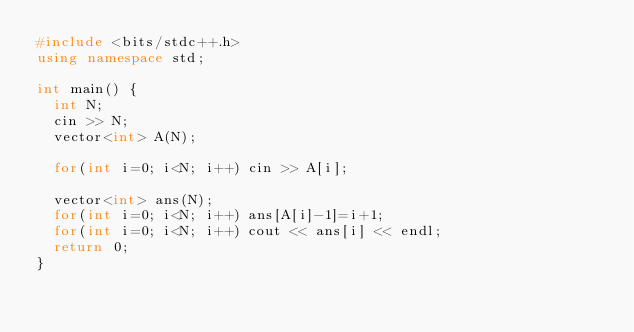<code> <loc_0><loc_0><loc_500><loc_500><_C++_>#include <bits/stdc++.h>
using namespace std;

int main() {
  int N;
  cin >> N;
  vector<int> A(N);
  
  for(int i=0; i<N; i++) cin >> A[i];
  
  vector<int> ans(N);
  for(int i=0; i<N; i++) ans[A[i]-1]=i+1;
  for(int i=0; i<N; i++) cout << ans[i] << endl;
  return 0;
}</code> 